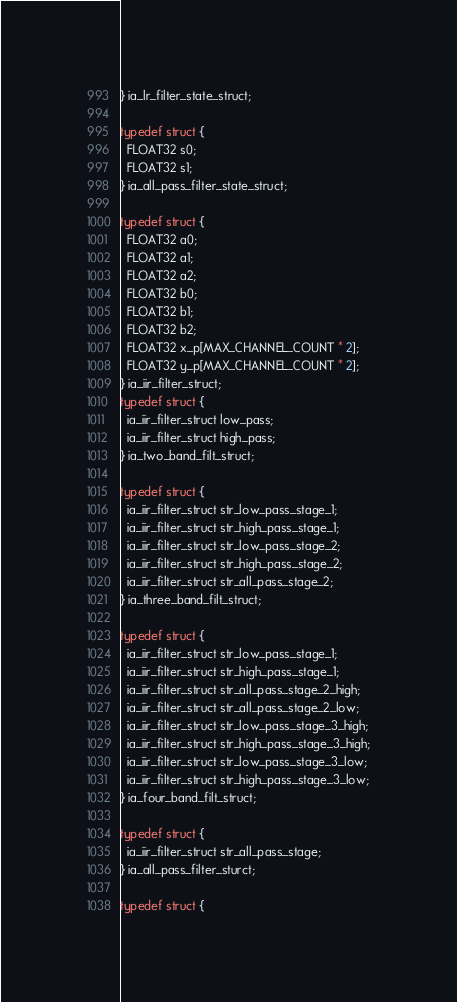Convert code to text. <code><loc_0><loc_0><loc_500><loc_500><_C_>} ia_lr_filter_state_struct;

typedef struct {
  FLOAT32 s0;
  FLOAT32 s1;
} ia_all_pass_filter_state_struct;

typedef struct {
  FLOAT32 a0;
  FLOAT32 a1;
  FLOAT32 a2;
  FLOAT32 b0;
  FLOAT32 b1;
  FLOAT32 b2;
  FLOAT32 x_p[MAX_CHANNEL_COUNT * 2];
  FLOAT32 y_p[MAX_CHANNEL_COUNT * 2];
} ia_iir_filter_struct;
typedef struct {
  ia_iir_filter_struct low_pass;
  ia_iir_filter_struct high_pass;
} ia_two_band_filt_struct;

typedef struct {
  ia_iir_filter_struct str_low_pass_stage_1;
  ia_iir_filter_struct str_high_pass_stage_1;
  ia_iir_filter_struct str_low_pass_stage_2;
  ia_iir_filter_struct str_high_pass_stage_2;
  ia_iir_filter_struct str_all_pass_stage_2;
} ia_three_band_filt_struct;

typedef struct {
  ia_iir_filter_struct str_low_pass_stage_1;
  ia_iir_filter_struct str_high_pass_stage_1;
  ia_iir_filter_struct str_all_pass_stage_2_high;
  ia_iir_filter_struct str_all_pass_stage_2_low;
  ia_iir_filter_struct str_low_pass_stage_3_high;
  ia_iir_filter_struct str_high_pass_stage_3_high;
  ia_iir_filter_struct str_low_pass_stage_3_low;
  ia_iir_filter_struct str_high_pass_stage_3_low;
} ia_four_band_filt_struct;

typedef struct {
  ia_iir_filter_struct str_all_pass_stage;
} ia_all_pass_filter_sturct;

typedef struct {</code> 